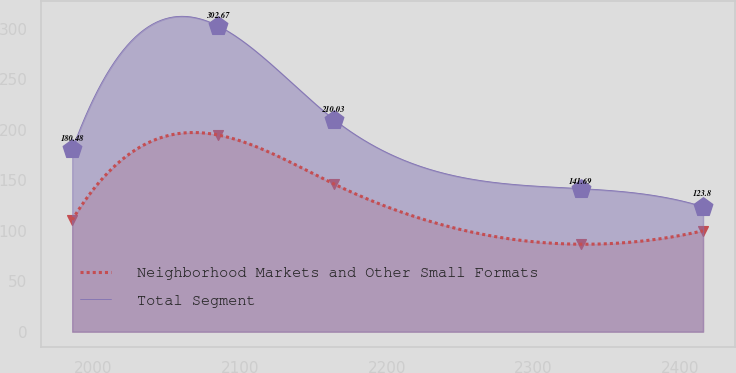Convert chart. <chart><loc_0><loc_0><loc_500><loc_500><line_chart><ecel><fcel>Neighborhood Markets and Other Small Formats<fcel>Total Segment<nl><fcel>1985.39<fcel>110.72<fcel>180.48<nl><fcel>2085.04<fcel>194.69<fcel>302.67<nl><fcel>2163.98<fcel>146.17<fcel>210.03<nl><fcel>2332.02<fcel>86.62<fcel>141.69<nl><fcel>2415.52<fcel>99.91<fcel>123.8<nl></chart> 